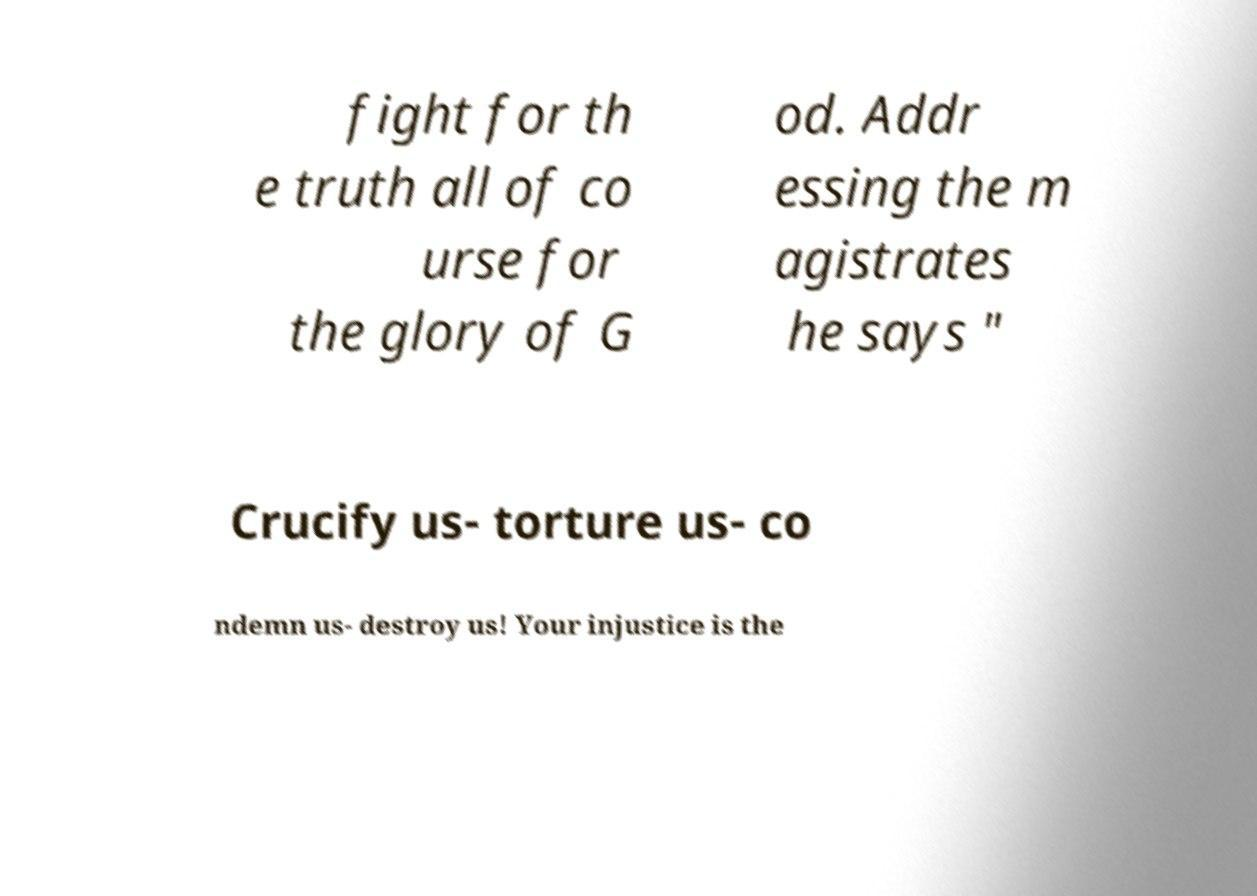Could you assist in decoding the text presented in this image and type it out clearly? fight for th e truth all of co urse for the glory of G od. Addr essing the m agistrates he says " Crucify us- torture us- co ndemn us- destroy us! Your injustice is the 